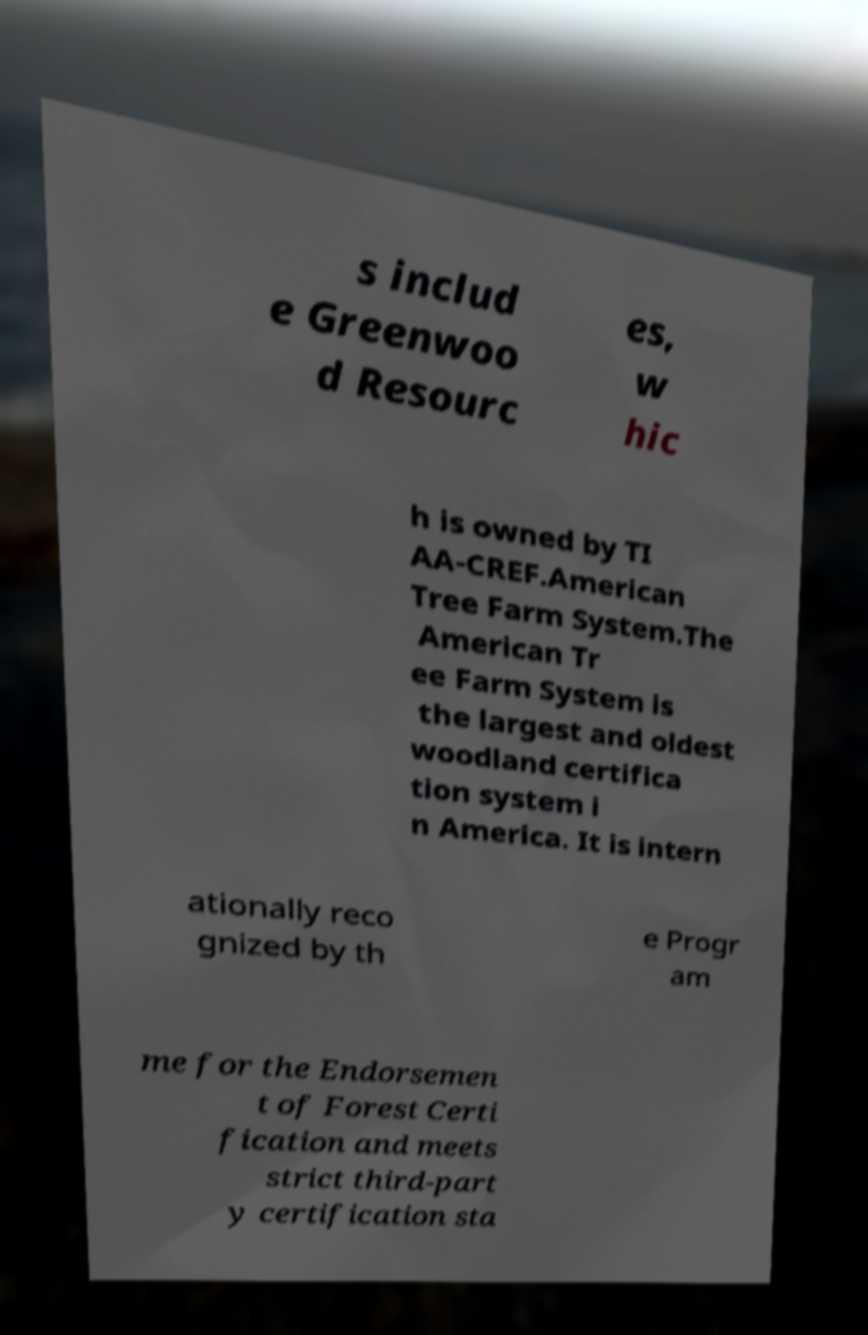There's text embedded in this image that I need extracted. Can you transcribe it verbatim? s includ e Greenwoo d Resourc es, w hic h is owned by TI AA-CREF.American Tree Farm System.The American Tr ee Farm System is the largest and oldest woodland certifica tion system i n America. It is intern ationally reco gnized by th e Progr am me for the Endorsemen t of Forest Certi fication and meets strict third-part y certification sta 